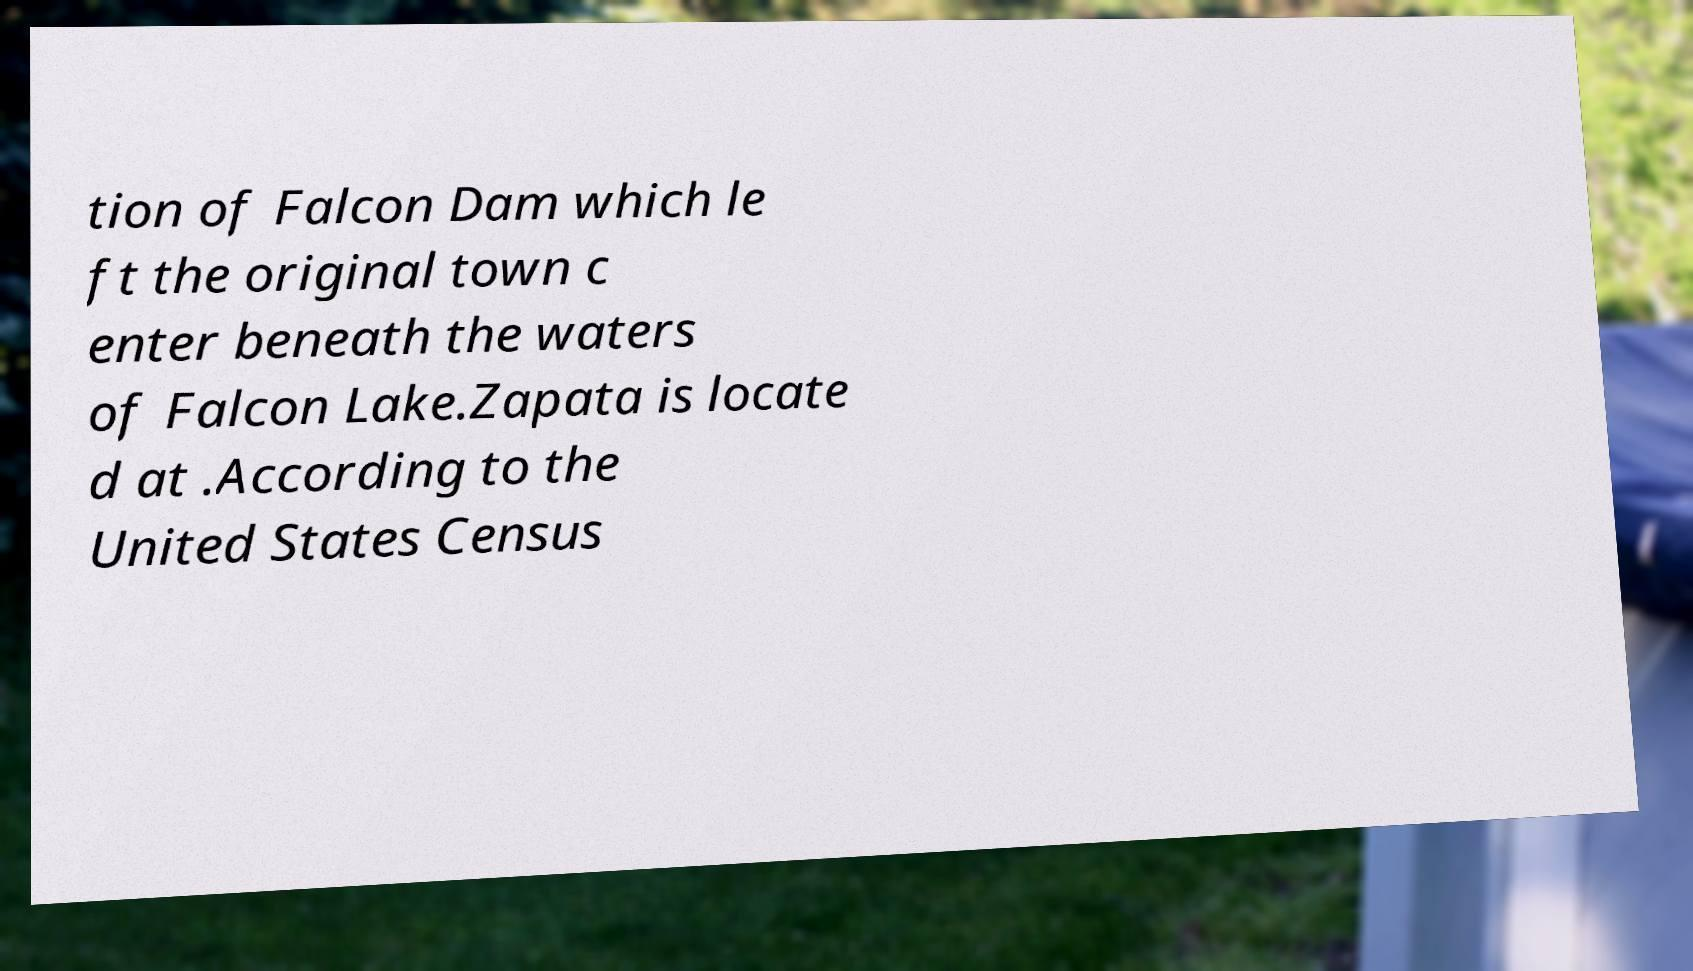Can you accurately transcribe the text from the provided image for me? tion of Falcon Dam which le ft the original town c enter beneath the waters of Falcon Lake.Zapata is locate d at .According to the United States Census 